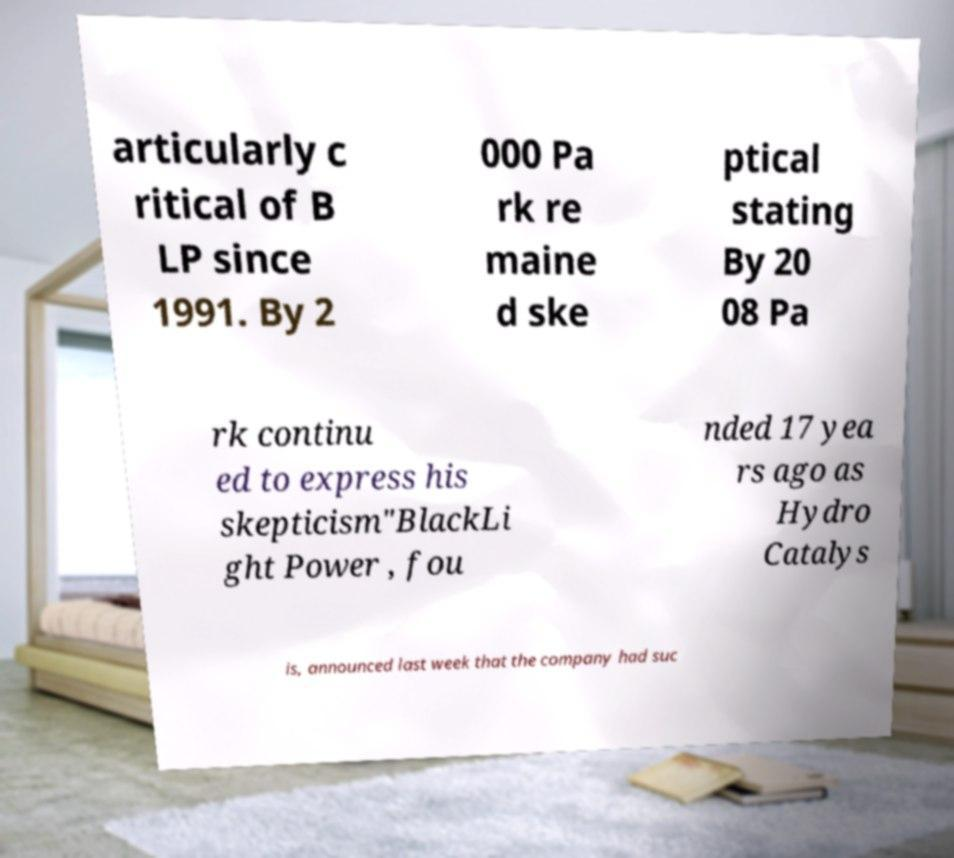There's text embedded in this image that I need extracted. Can you transcribe it verbatim? articularly c ritical of B LP since 1991. By 2 000 Pa rk re maine d ske ptical stating By 20 08 Pa rk continu ed to express his skepticism"BlackLi ght Power , fou nded 17 yea rs ago as Hydro Catalys is, announced last week that the company had suc 